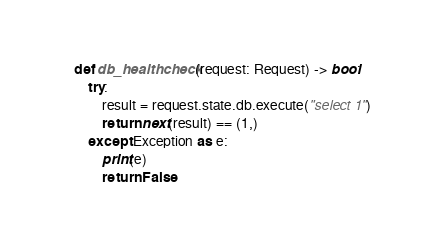Convert code to text. <code><loc_0><loc_0><loc_500><loc_500><_Python_>
def db_healthcheck(request: Request) -> bool:
    try:
        result = request.state.db.execute("select 1")
        return next(result) == (1,)
    except Exception as e:
        print(e)
        return False
</code> 